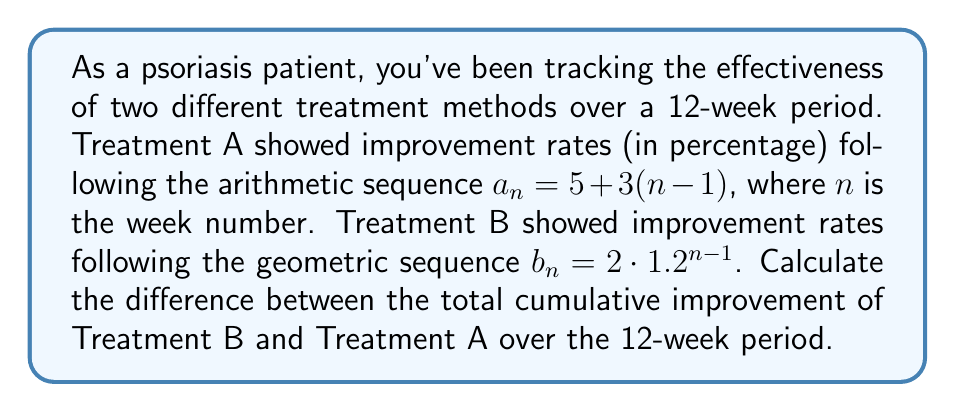Provide a solution to this math problem. Let's approach this step-by-step:

1) For Treatment A (arithmetic sequence):
   $a_n = 5 + 3(n-1)$
   Sum of arithmetic sequence: $S_n = \frac{n}{2}(a_1 + a_n)$
   $a_1 = 5$
   $a_{12} = 5 + 3(12-1) = 38$
   $S_{12} = \frac{12}{2}(5 + 38) = 6 \cdot 43 = 258$

2) For Treatment B (geometric sequence):
   $b_n = 2 \cdot 1.2^{n-1}$
   Sum of geometric sequence: $S_n = \frac{a_1(1-r^n)}{1-r}$, where $r$ is the common ratio
   $a_1 = 2$
   $r = 1.2$
   $S_{12} = \frac{2(1-1.2^{12})}{1-1.2} = \frac{2(1-8.916)}{-0.2} = 79.16$

3) Difference between Treatment B and Treatment A:
   $79.16 - 258 = -178.84$
Answer: $-178.84$ 